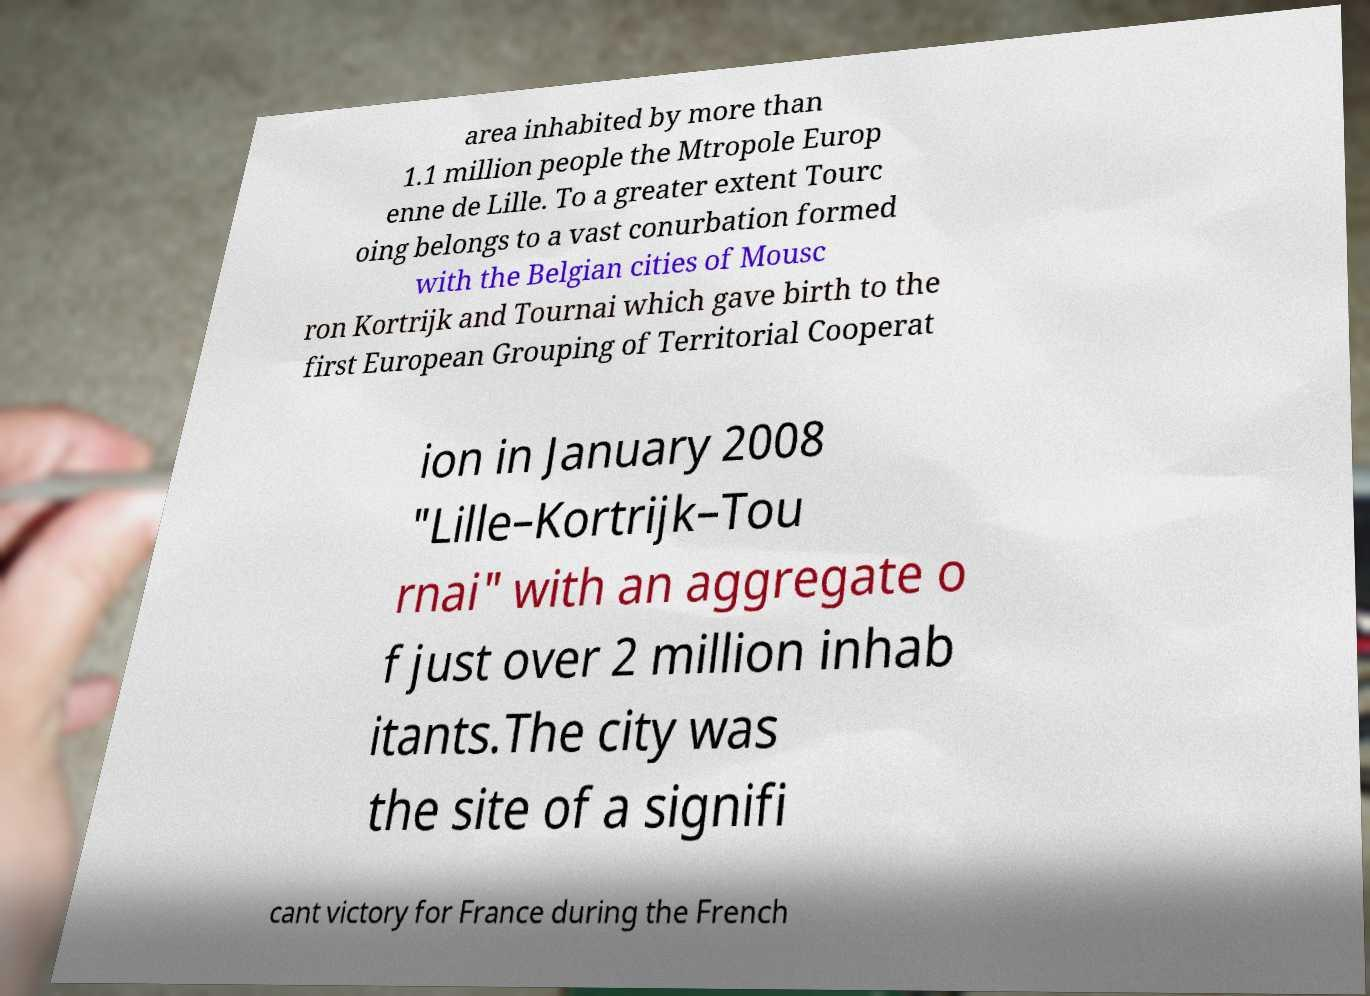For documentation purposes, I need the text within this image transcribed. Could you provide that? area inhabited by more than 1.1 million people the Mtropole Europ enne de Lille. To a greater extent Tourc oing belongs to a vast conurbation formed with the Belgian cities of Mousc ron Kortrijk and Tournai which gave birth to the first European Grouping of Territorial Cooperat ion in January 2008 "Lille–Kortrijk–Tou rnai" with an aggregate o f just over 2 million inhab itants.The city was the site of a signifi cant victory for France during the French 